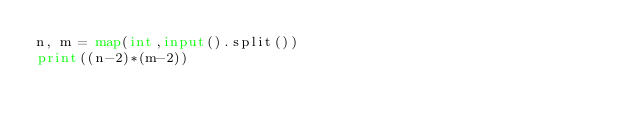<code> <loc_0><loc_0><loc_500><loc_500><_Python_>n, m = map(int,input().split())
print((n-2)*(m-2))</code> 